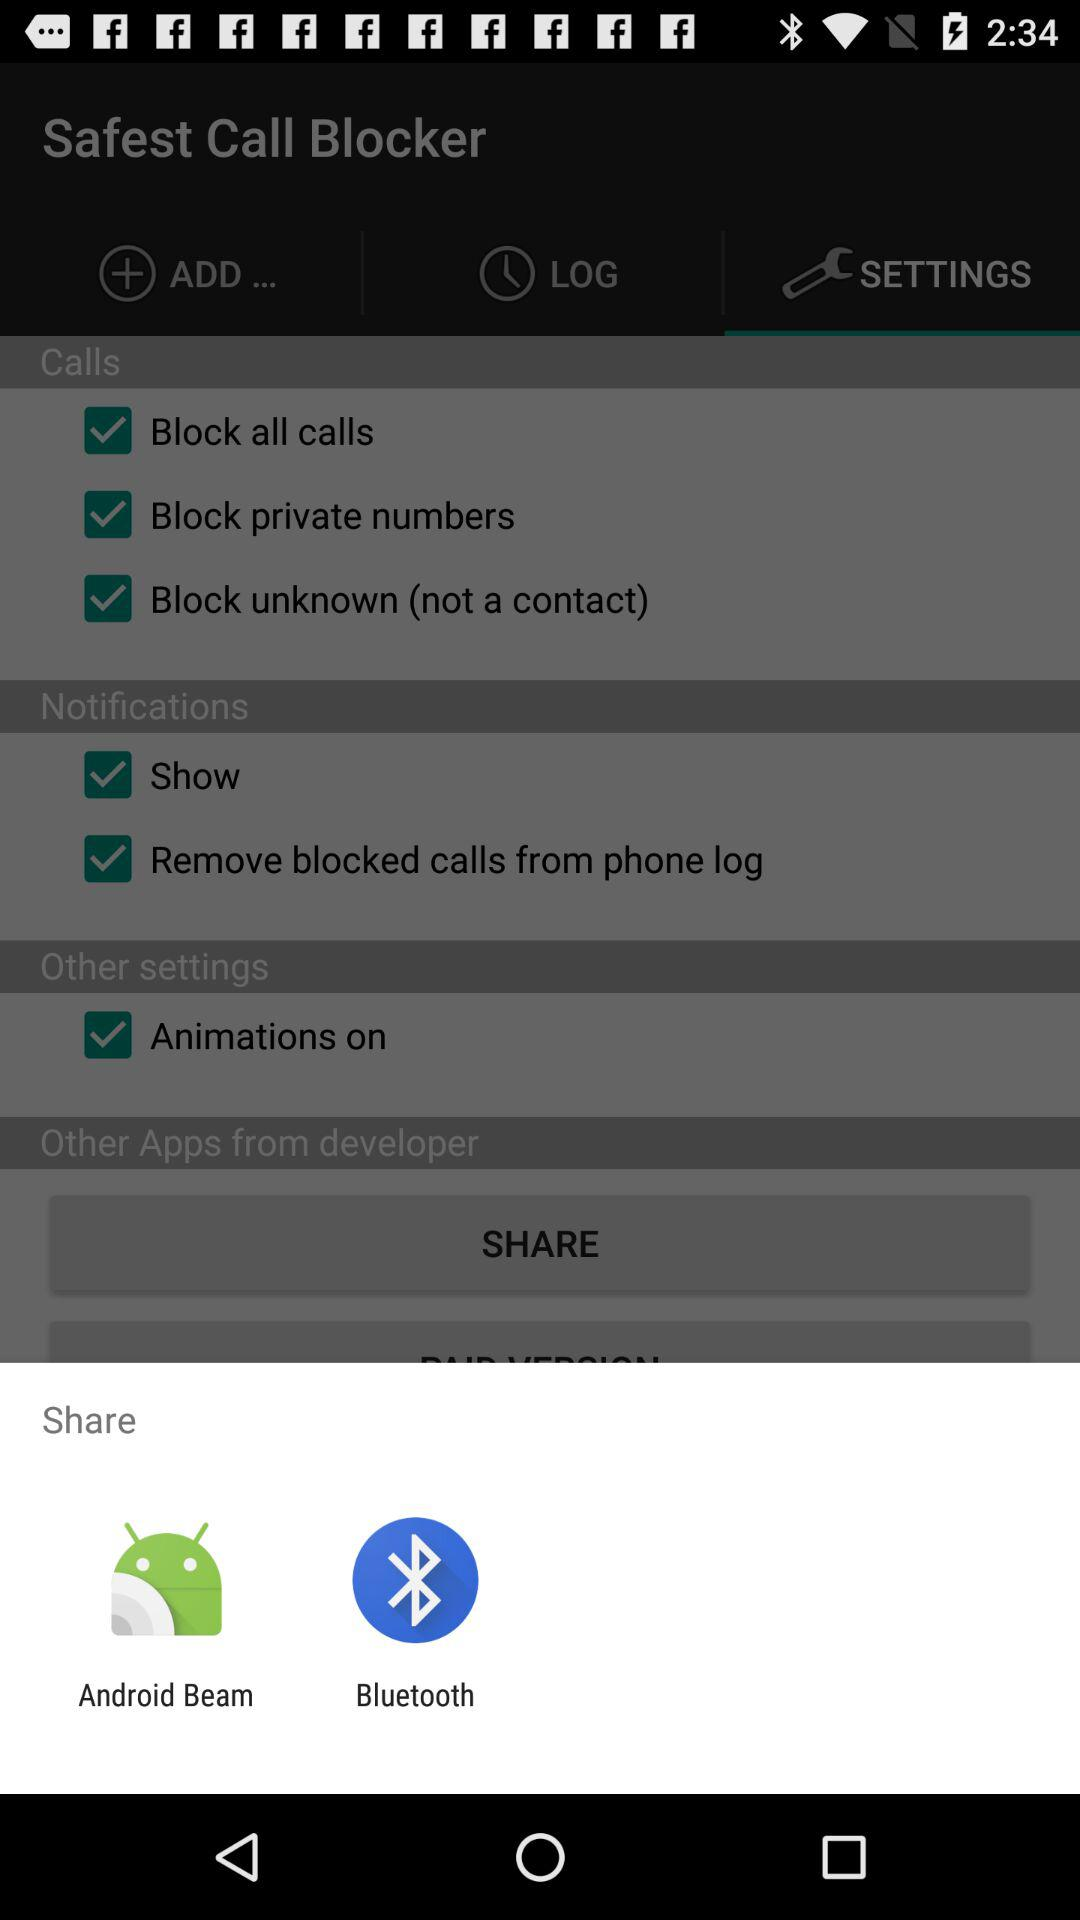How many check boxes are in the Notifications section?
Answer the question using a single word or phrase. 2 